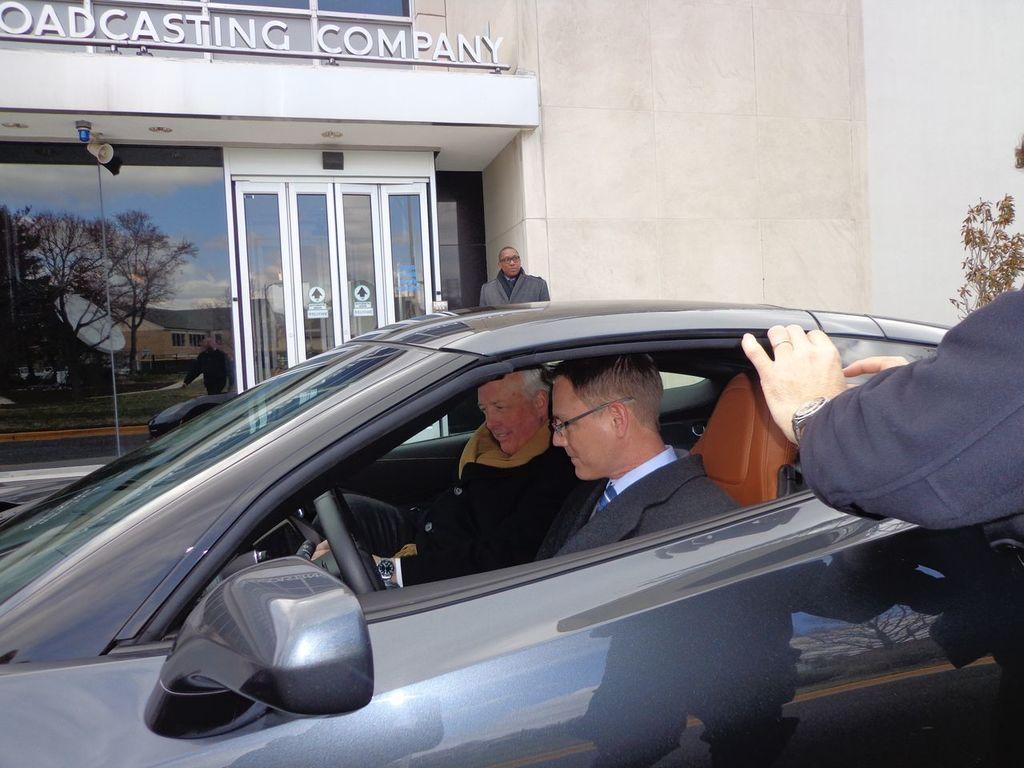Can you describe this image briefly? This is a car. There are two people sitting inside the car. I can see a person standing. this looks like a building with glass doors. This is the name board. At the right corner of the image I can see person hand. I can see reflection of trees,building on the glass. I think these are the lights attached to the rooftop. 